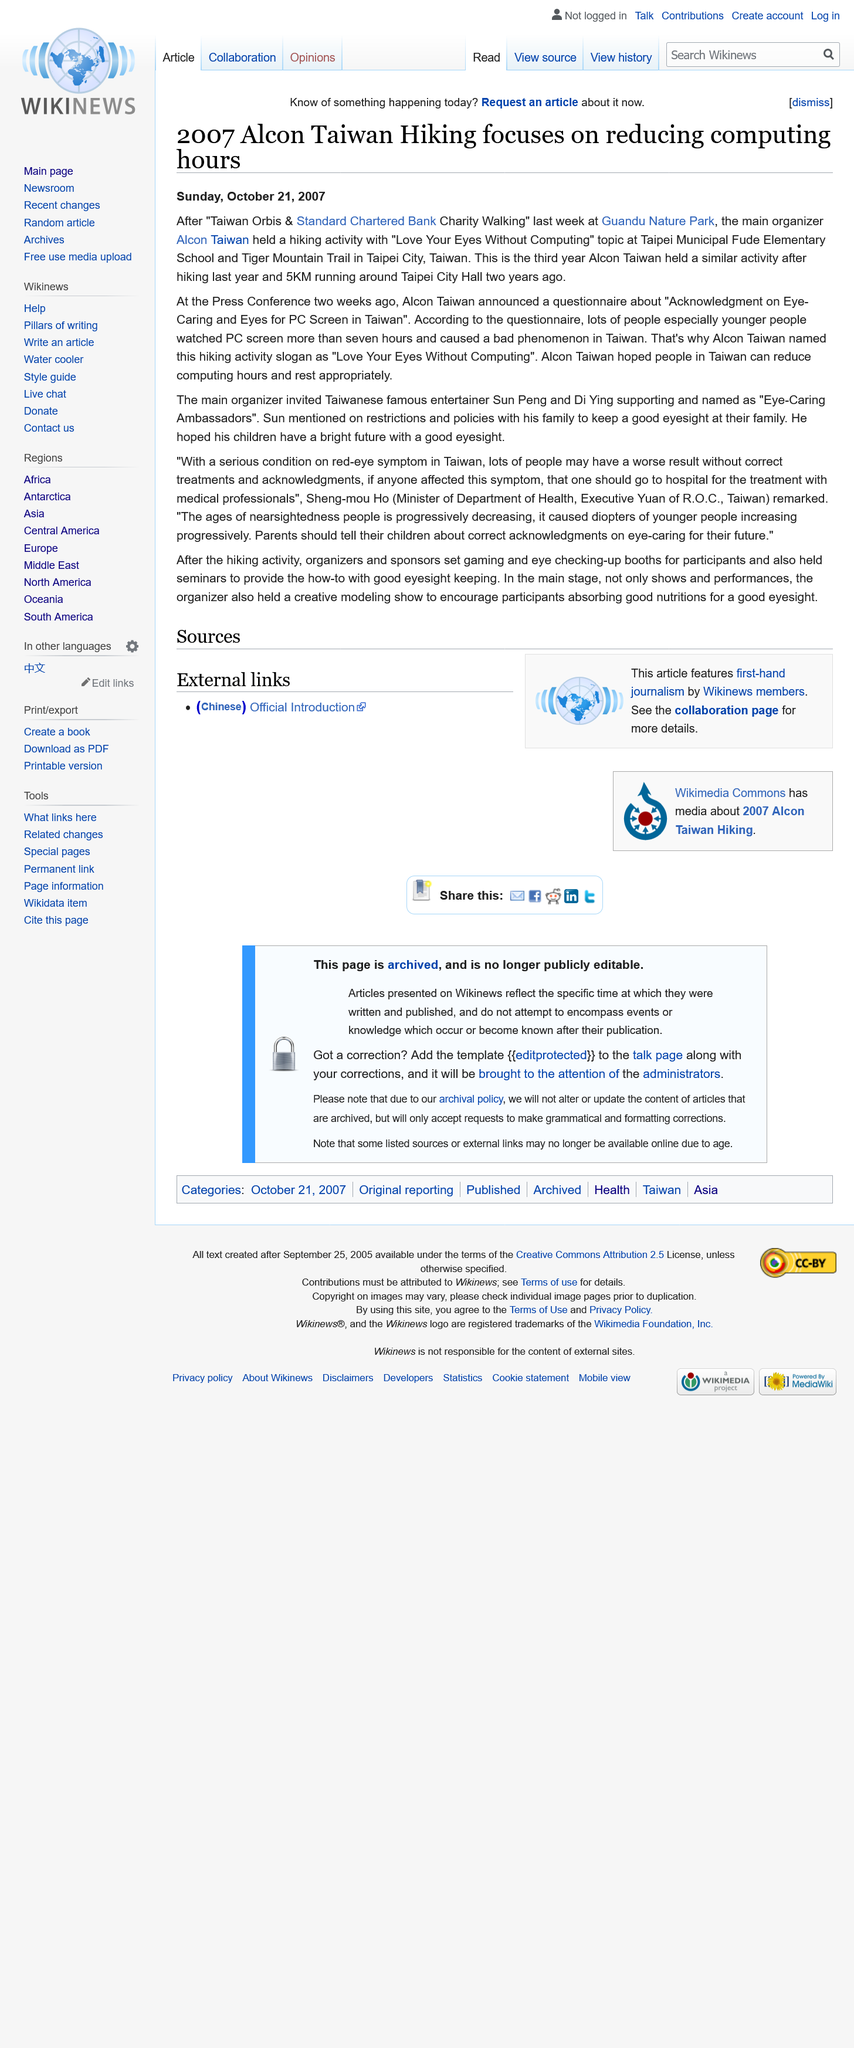List a handful of essential elements in this visual. The Taiwan Orbis and Standard Chartered Bank Charity Walking was held at Guandu Nature Park. Alcon Taiwan has held an activity to reduce computing hours for 14 years, since 2007, which was the third year the company held such activities. The slogan for the hiking activity was "Love Your Eyes Without Computing," which emphasized the importance of taking breaks from digital devices and enjoying the natural beauty around us. 